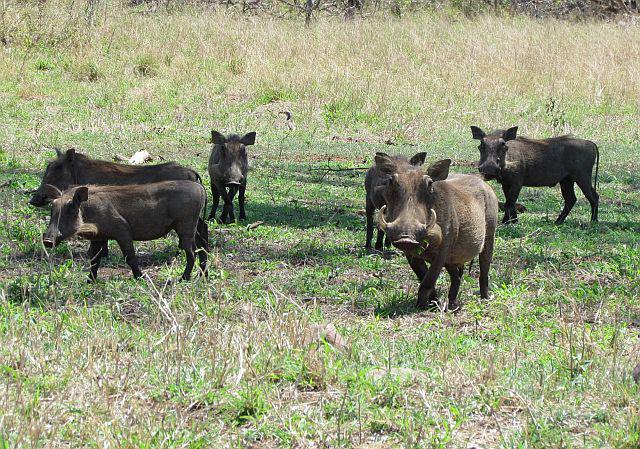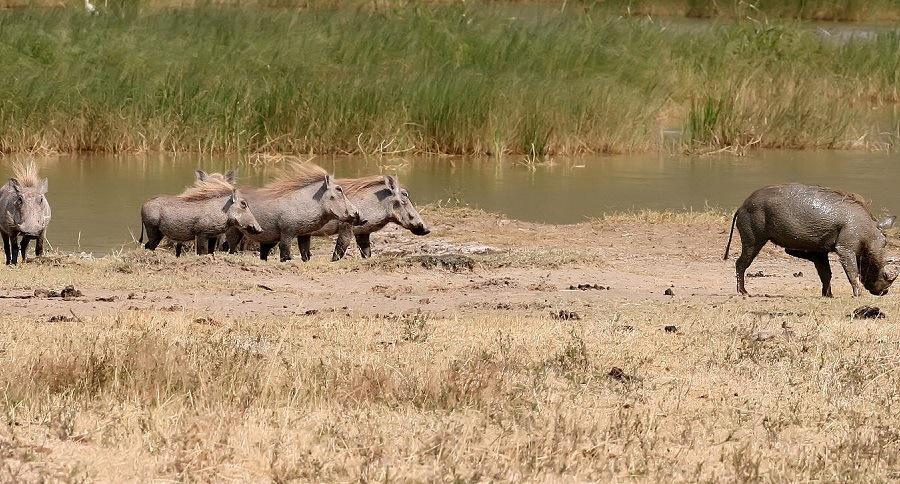The first image is the image on the left, the second image is the image on the right. Given the left and right images, does the statement "There are exactly five animals in the image on the right." hold true? Answer yes or no. Yes. 